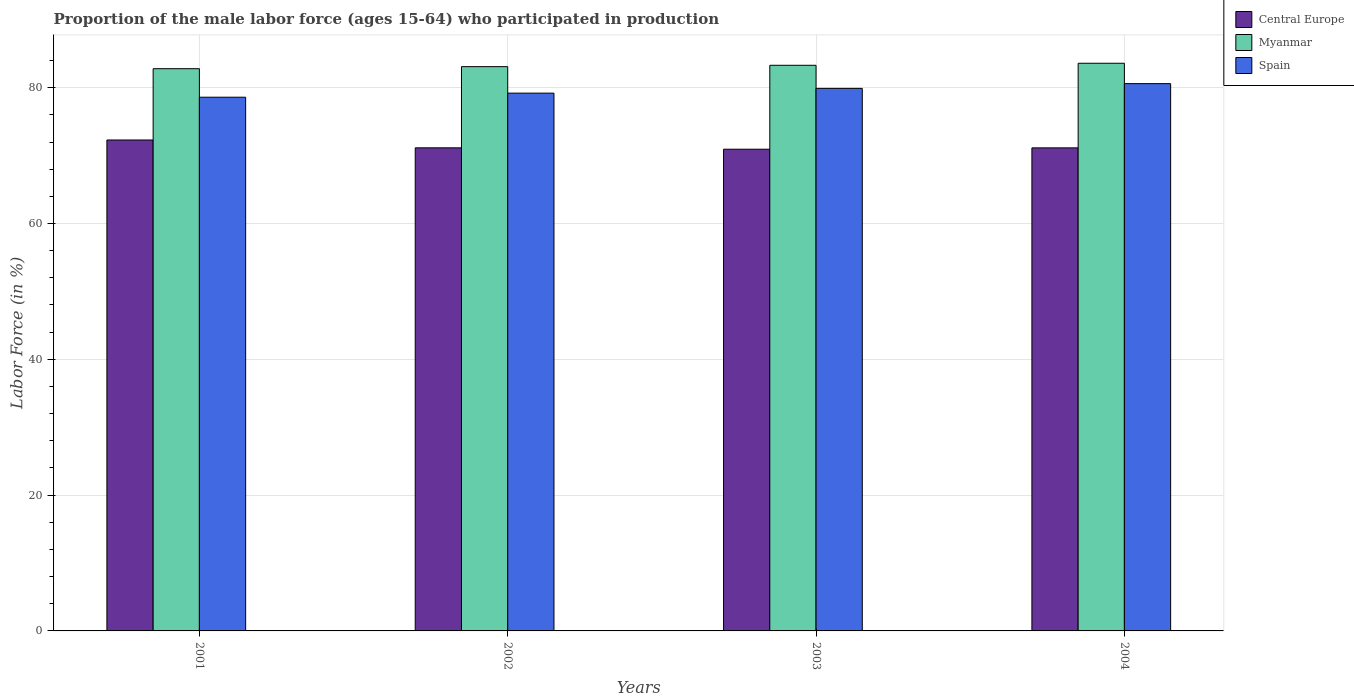How many different coloured bars are there?
Your response must be concise. 3. How many groups of bars are there?
Offer a terse response. 4. Are the number of bars per tick equal to the number of legend labels?
Provide a short and direct response. Yes. Are the number of bars on each tick of the X-axis equal?
Offer a terse response. Yes. How many bars are there on the 4th tick from the left?
Your response must be concise. 3. What is the label of the 2nd group of bars from the left?
Keep it short and to the point. 2002. What is the proportion of the male labor force who participated in production in Central Europe in 2004?
Offer a very short reply. 71.14. Across all years, what is the maximum proportion of the male labor force who participated in production in Myanmar?
Provide a succinct answer. 83.6. Across all years, what is the minimum proportion of the male labor force who participated in production in Myanmar?
Give a very brief answer. 82.8. In which year was the proportion of the male labor force who participated in production in Myanmar minimum?
Offer a terse response. 2001. What is the total proportion of the male labor force who participated in production in Central Europe in the graph?
Your answer should be very brief. 285.53. What is the difference between the proportion of the male labor force who participated in production in Myanmar in 2001 and that in 2003?
Your answer should be very brief. -0.5. What is the difference between the proportion of the male labor force who participated in production in Spain in 2001 and the proportion of the male labor force who participated in production in Central Europe in 2004?
Keep it short and to the point. 7.46. What is the average proportion of the male labor force who participated in production in Central Europe per year?
Your answer should be compact. 71.38. In the year 2001, what is the difference between the proportion of the male labor force who participated in production in Spain and proportion of the male labor force who participated in production in Myanmar?
Ensure brevity in your answer.  -4.2. In how many years, is the proportion of the male labor force who participated in production in Spain greater than 32 %?
Your answer should be very brief. 4. What is the ratio of the proportion of the male labor force who participated in production in Spain in 2001 to that in 2004?
Offer a terse response. 0.98. Is the difference between the proportion of the male labor force who participated in production in Spain in 2003 and 2004 greater than the difference between the proportion of the male labor force who participated in production in Myanmar in 2003 and 2004?
Offer a terse response. No. What is the difference between the highest and the second highest proportion of the male labor force who participated in production in Spain?
Make the answer very short. 0.7. What is the difference between the highest and the lowest proportion of the male labor force who participated in production in Central Europe?
Offer a very short reply. 1.36. In how many years, is the proportion of the male labor force who participated in production in Myanmar greater than the average proportion of the male labor force who participated in production in Myanmar taken over all years?
Offer a very short reply. 2. Is the sum of the proportion of the male labor force who participated in production in Central Europe in 2003 and 2004 greater than the maximum proportion of the male labor force who participated in production in Spain across all years?
Offer a terse response. Yes. What does the 3rd bar from the left in 2004 represents?
Your answer should be compact. Spain. What does the 3rd bar from the right in 2004 represents?
Make the answer very short. Central Europe. Is it the case that in every year, the sum of the proportion of the male labor force who participated in production in Myanmar and proportion of the male labor force who participated in production in Central Europe is greater than the proportion of the male labor force who participated in production in Spain?
Give a very brief answer. Yes. How many bars are there?
Your response must be concise. 12. What is the difference between two consecutive major ticks on the Y-axis?
Your response must be concise. 20. Does the graph contain any zero values?
Make the answer very short. No. Does the graph contain grids?
Give a very brief answer. Yes. How are the legend labels stacked?
Offer a terse response. Vertical. What is the title of the graph?
Provide a short and direct response. Proportion of the male labor force (ages 15-64) who participated in production. Does "Tuvalu" appear as one of the legend labels in the graph?
Provide a short and direct response. No. What is the label or title of the X-axis?
Keep it short and to the point. Years. What is the Labor Force (in %) in Central Europe in 2001?
Ensure brevity in your answer.  72.3. What is the Labor Force (in %) of Myanmar in 2001?
Provide a short and direct response. 82.8. What is the Labor Force (in %) in Spain in 2001?
Your answer should be very brief. 78.6. What is the Labor Force (in %) of Central Europe in 2002?
Your answer should be very brief. 71.15. What is the Labor Force (in %) of Myanmar in 2002?
Your answer should be very brief. 83.1. What is the Labor Force (in %) of Spain in 2002?
Provide a short and direct response. 79.2. What is the Labor Force (in %) in Central Europe in 2003?
Make the answer very short. 70.94. What is the Labor Force (in %) of Myanmar in 2003?
Provide a succinct answer. 83.3. What is the Labor Force (in %) of Spain in 2003?
Your response must be concise. 79.9. What is the Labor Force (in %) of Central Europe in 2004?
Provide a short and direct response. 71.14. What is the Labor Force (in %) of Myanmar in 2004?
Give a very brief answer. 83.6. What is the Labor Force (in %) in Spain in 2004?
Provide a succinct answer. 80.6. Across all years, what is the maximum Labor Force (in %) of Central Europe?
Your answer should be very brief. 72.3. Across all years, what is the maximum Labor Force (in %) of Myanmar?
Keep it short and to the point. 83.6. Across all years, what is the maximum Labor Force (in %) of Spain?
Provide a short and direct response. 80.6. Across all years, what is the minimum Labor Force (in %) of Central Europe?
Keep it short and to the point. 70.94. Across all years, what is the minimum Labor Force (in %) of Myanmar?
Your response must be concise. 82.8. Across all years, what is the minimum Labor Force (in %) in Spain?
Give a very brief answer. 78.6. What is the total Labor Force (in %) in Central Europe in the graph?
Your answer should be very brief. 285.53. What is the total Labor Force (in %) of Myanmar in the graph?
Your answer should be compact. 332.8. What is the total Labor Force (in %) in Spain in the graph?
Ensure brevity in your answer.  318.3. What is the difference between the Labor Force (in %) in Central Europe in 2001 and that in 2002?
Make the answer very short. 1.16. What is the difference between the Labor Force (in %) of Central Europe in 2001 and that in 2003?
Provide a short and direct response. 1.36. What is the difference between the Labor Force (in %) in Spain in 2001 and that in 2003?
Your answer should be very brief. -1.3. What is the difference between the Labor Force (in %) of Central Europe in 2001 and that in 2004?
Your answer should be very brief. 1.16. What is the difference between the Labor Force (in %) in Myanmar in 2001 and that in 2004?
Your answer should be compact. -0.8. What is the difference between the Labor Force (in %) in Spain in 2001 and that in 2004?
Provide a short and direct response. -2. What is the difference between the Labor Force (in %) of Central Europe in 2002 and that in 2003?
Make the answer very short. 0.2. What is the difference between the Labor Force (in %) of Myanmar in 2002 and that in 2003?
Your response must be concise. -0.2. What is the difference between the Labor Force (in %) in Central Europe in 2002 and that in 2004?
Your answer should be very brief. 0. What is the difference between the Labor Force (in %) in Spain in 2002 and that in 2004?
Your answer should be compact. -1.4. What is the difference between the Labor Force (in %) in Central Europe in 2003 and that in 2004?
Your answer should be compact. -0.2. What is the difference between the Labor Force (in %) in Central Europe in 2001 and the Labor Force (in %) in Myanmar in 2002?
Your answer should be very brief. -10.8. What is the difference between the Labor Force (in %) of Central Europe in 2001 and the Labor Force (in %) of Spain in 2002?
Provide a succinct answer. -6.9. What is the difference between the Labor Force (in %) in Myanmar in 2001 and the Labor Force (in %) in Spain in 2002?
Make the answer very short. 3.6. What is the difference between the Labor Force (in %) of Central Europe in 2001 and the Labor Force (in %) of Myanmar in 2003?
Your answer should be compact. -11. What is the difference between the Labor Force (in %) in Central Europe in 2001 and the Labor Force (in %) in Spain in 2003?
Provide a short and direct response. -7.6. What is the difference between the Labor Force (in %) of Myanmar in 2001 and the Labor Force (in %) of Spain in 2003?
Offer a terse response. 2.9. What is the difference between the Labor Force (in %) of Central Europe in 2001 and the Labor Force (in %) of Myanmar in 2004?
Your answer should be compact. -11.3. What is the difference between the Labor Force (in %) in Central Europe in 2001 and the Labor Force (in %) in Spain in 2004?
Your answer should be very brief. -8.3. What is the difference between the Labor Force (in %) of Myanmar in 2001 and the Labor Force (in %) of Spain in 2004?
Make the answer very short. 2.2. What is the difference between the Labor Force (in %) in Central Europe in 2002 and the Labor Force (in %) in Myanmar in 2003?
Offer a terse response. -12.15. What is the difference between the Labor Force (in %) of Central Europe in 2002 and the Labor Force (in %) of Spain in 2003?
Offer a very short reply. -8.75. What is the difference between the Labor Force (in %) in Myanmar in 2002 and the Labor Force (in %) in Spain in 2003?
Your answer should be compact. 3.2. What is the difference between the Labor Force (in %) in Central Europe in 2002 and the Labor Force (in %) in Myanmar in 2004?
Provide a short and direct response. -12.45. What is the difference between the Labor Force (in %) of Central Europe in 2002 and the Labor Force (in %) of Spain in 2004?
Keep it short and to the point. -9.45. What is the difference between the Labor Force (in %) in Central Europe in 2003 and the Labor Force (in %) in Myanmar in 2004?
Your answer should be compact. -12.66. What is the difference between the Labor Force (in %) of Central Europe in 2003 and the Labor Force (in %) of Spain in 2004?
Make the answer very short. -9.66. What is the difference between the Labor Force (in %) of Myanmar in 2003 and the Labor Force (in %) of Spain in 2004?
Make the answer very short. 2.7. What is the average Labor Force (in %) of Central Europe per year?
Ensure brevity in your answer.  71.38. What is the average Labor Force (in %) of Myanmar per year?
Ensure brevity in your answer.  83.2. What is the average Labor Force (in %) of Spain per year?
Offer a very short reply. 79.58. In the year 2001, what is the difference between the Labor Force (in %) in Central Europe and Labor Force (in %) in Myanmar?
Give a very brief answer. -10.5. In the year 2001, what is the difference between the Labor Force (in %) in Central Europe and Labor Force (in %) in Spain?
Your answer should be very brief. -6.3. In the year 2001, what is the difference between the Labor Force (in %) of Myanmar and Labor Force (in %) of Spain?
Provide a succinct answer. 4.2. In the year 2002, what is the difference between the Labor Force (in %) of Central Europe and Labor Force (in %) of Myanmar?
Ensure brevity in your answer.  -11.95. In the year 2002, what is the difference between the Labor Force (in %) of Central Europe and Labor Force (in %) of Spain?
Ensure brevity in your answer.  -8.05. In the year 2002, what is the difference between the Labor Force (in %) in Myanmar and Labor Force (in %) in Spain?
Your answer should be very brief. 3.9. In the year 2003, what is the difference between the Labor Force (in %) in Central Europe and Labor Force (in %) in Myanmar?
Keep it short and to the point. -12.36. In the year 2003, what is the difference between the Labor Force (in %) in Central Europe and Labor Force (in %) in Spain?
Ensure brevity in your answer.  -8.96. In the year 2003, what is the difference between the Labor Force (in %) in Myanmar and Labor Force (in %) in Spain?
Provide a short and direct response. 3.4. In the year 2004, what is the difference between the Labor Force (in %) of Central Europe and Labor Force (in %) of Myanmar?
Your answer should be very brief. -12.46. In the year 2004, what is the difference between the Labor Force (in %) of Central Europe and Labor Force (in %) of Spain?
Offer a terse response. -9.46. In the year 2004, what is the difference between the Labor Force (in %) in Myanmar and Labor Force (in %) in Spain?
Provide a succinct answer. 3. What is the ratio of the Labor Force (in %) in Central Europe in 2001 to that in 2002?
Provide a short and direct response. 1.02. What is the ratio of the Labor Force (in %) in Myanmar in 2001 to that in 2002?
Your answer should be compact. 1. What is the ratio of the Labor Force (in %) of Spain in 2001 to that in 2002?
Your answer should be compact. 0.99. What is the ratio of the Labor Force (in %) of Central Europe in 2001 to that in 2003?
Your response must be concise. 1.02. What is the ratio of the Labor Force (in %) of Spain in 2001 to that in 2003?
Your answer should be compact. 0.98. What is the ratio of the Labor Force (in %) of Central Europe in 2001 to that in 2004?
Provide a short and direct response. 1.02. What is the ratio of the Labor Force (in %) of Myanmar in 2001 to that in 2004?
Make the answer very short. 0.99. What is the ratio of the Labor Force (in %) of Spain in 2001 to that in 2004?
Give a very brief answer. 0.98. What is the ratio of the Labor Force (in %) of Central Europe in 2002 to that in 2003?
Keep it short and to the point. 1. What is the ratio of the Labor Force (in %) in Spain in 2002 to that in 2003?
Your answer should be very brief. 0.99. What is the ratio of the Labor Force (in %) in Spain in 2002 to that in 2004?
Provide a short and direct response. 0.98. What is the difference between the highest and the second highest Labor Force (in %) of Central Europe?
Give a very brief answer. 1.16. What is the difference between the highest and the second highest Labor Force (in %) of Spain?
Your answer should be very brief. 0.7. What is the difference between the highest and the lowest Labor Force (in %) of Central Europe?
Give a very brief answer. 1.36. What is the difference between the highest and the lowest Labor Force (in %) in Myanmar?
Your response must be concise. 0.8. 